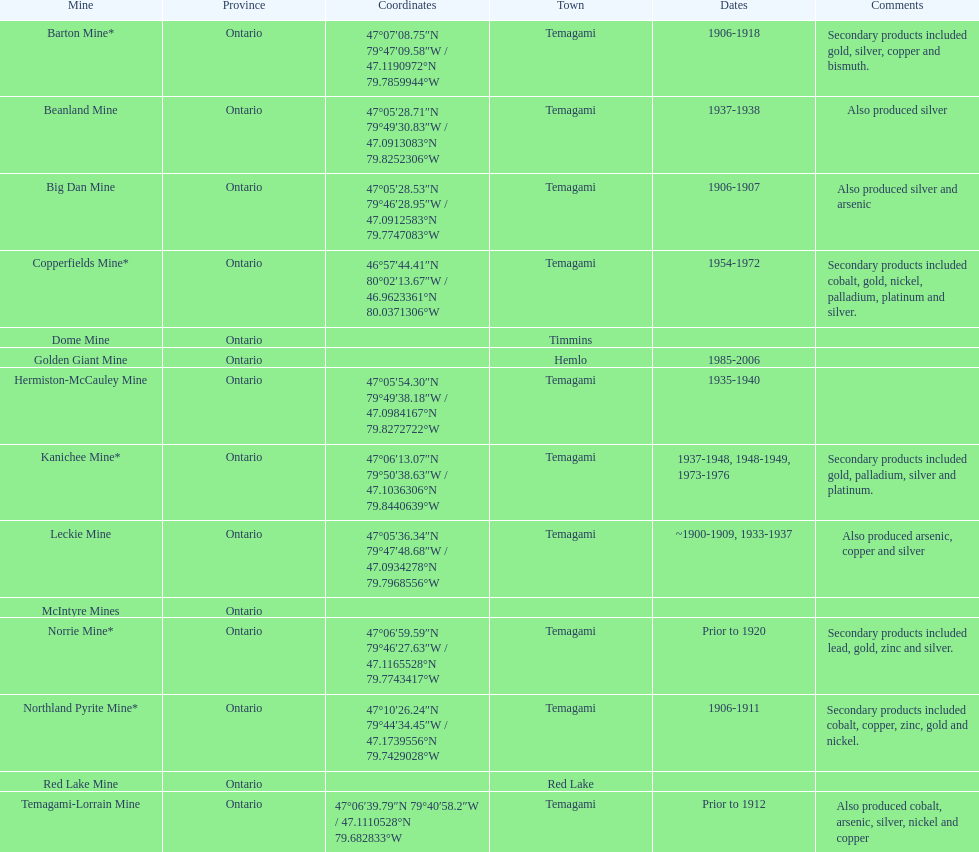What number of mines existed in temagami? 10. 